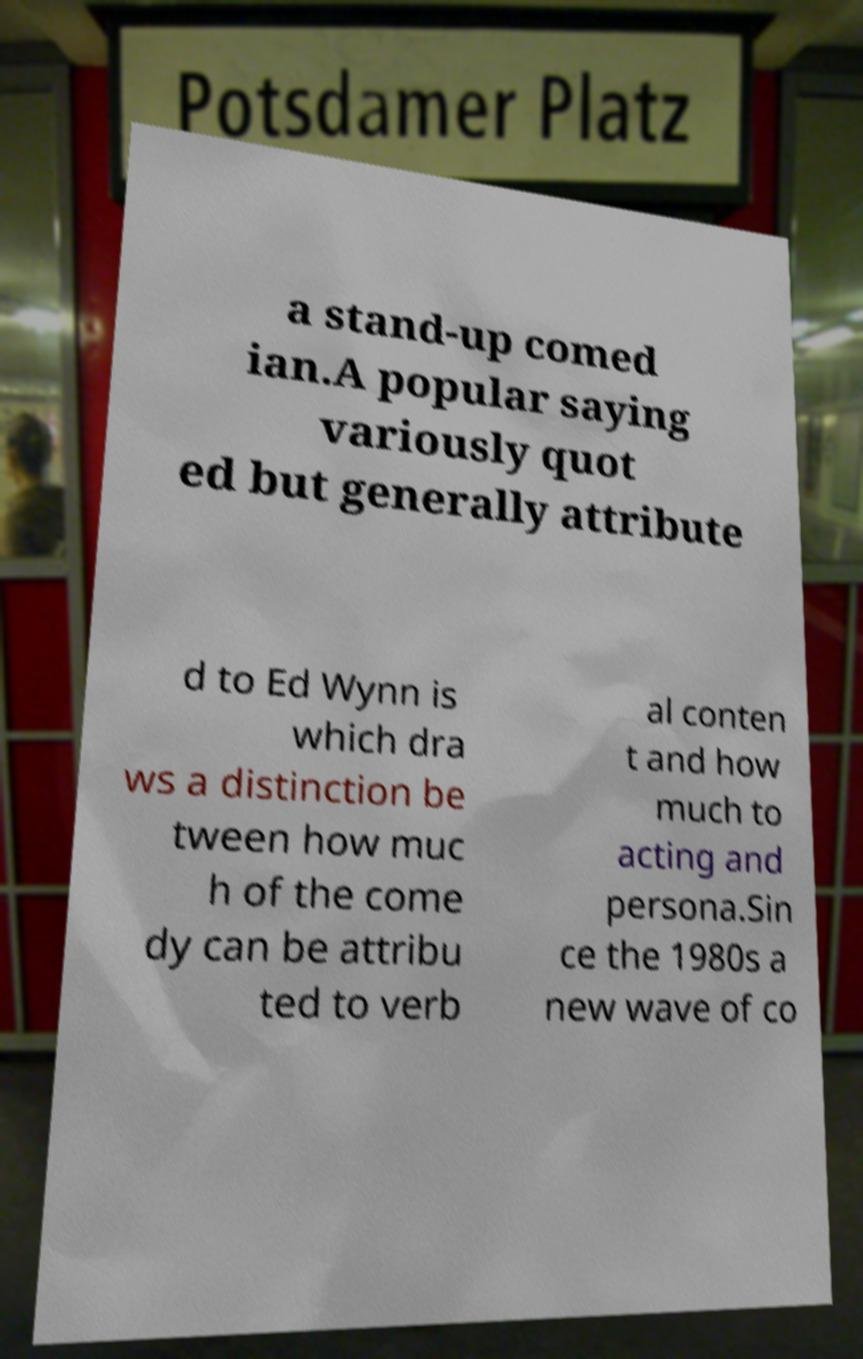Could you assist in decoding the text presented in this image and type it out clearly? a stand-up comed ian.A popular saying variously quot ed but generally attribute d to Ed Wynn is which dra ws a distinction be tween how muc h of the come dy can be attribu ted to verb al conten t and how much to acting and persona.Sin ce the 1980s a new wave of co 